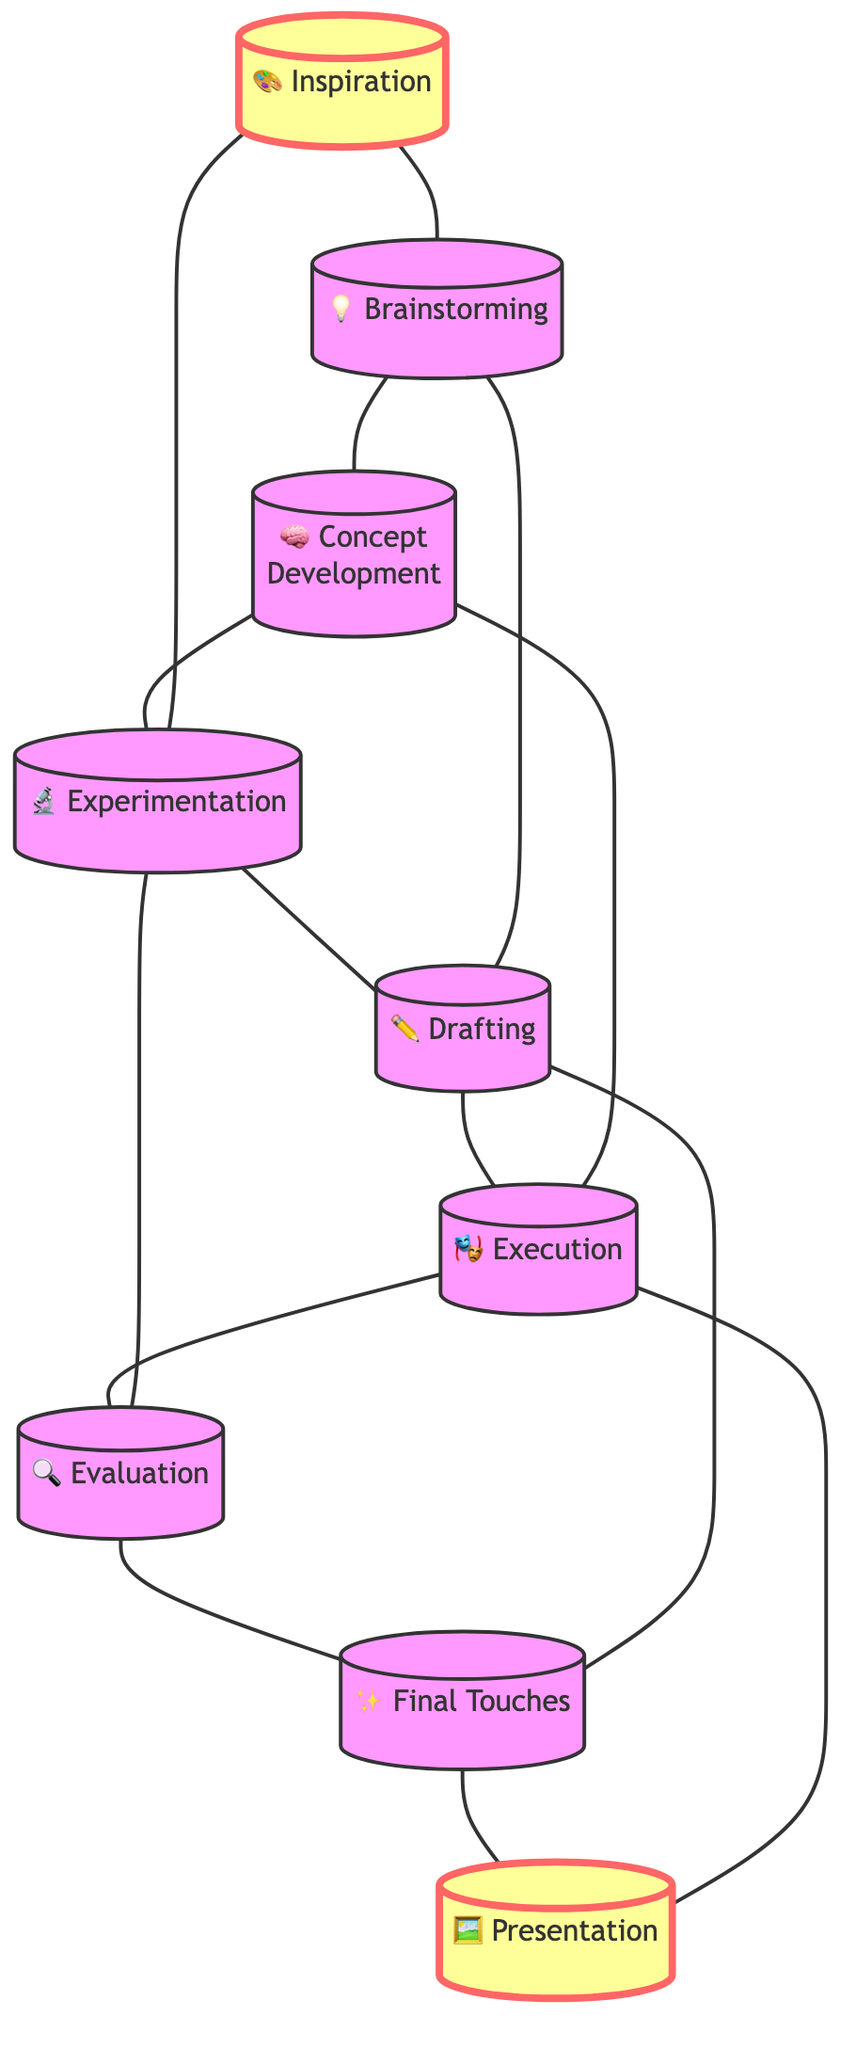What is the first stage of the creative process? The first stage of the creative process is labeled as "Inspiration." It is the starting point and is represented by the node connected to other stages of the diagram.
Answer: Inspiration How many stages are there in the creative process? The diagram contains nine stages, as indicated by the nodes present. Each node represents a distinct stage, and counting them gives the total.
Answer: Nine What stage comes after Drafting? According to the connections in the diagram, the stage that follows Drafting is Execution. This can be determined by following the direct connection from Drafting to Execution.
Answer: Execution Which two stages are directly connected to Brainstorming? Brainstorming is connected to Inspiration and Concept Development. By inspecting the edges connected to the Brainstorming node, one can see its direct relationships.
Answer: Inspiration and Concept Development Which stage has the most connections? Experimentation has multiple connections, linking it to several other stages. By analyzing the number of edges attached to each node, we find Experimentation connects to four different stages, making it the most connected stage.
Answer: Experimentation How do Inspiration and Evaluation relate in the creative process? Inspiration and Evaluation are indirectly related through multiple paths. Inspiration leads to several stages, but Evaluation follows a separate path; however, both connect back to creative outcomes, indicating a non-linear relationship.
Answer: Indirectly connected What is the final stage of the creative process? The final stage in the diagram is Presentation, which is indicated as the last node in the sequence of connections, following Final Touches.
Answer: Presentation Which two stages are both related to the concept of feedback? The stages related to feedback are Evaluation and Final Touches. Evaluation directly involves reflecting on the piece and seeking feedback, while Final Touches implies refining based on feedback as well.
Answer: Evaluation and Final Touches How many direct connections does Execution have? Execution has three direct connections in the diagram. By observing the edges that connect to the Execution node, we can count them.
Answer: Three 